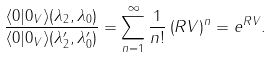Convert formula to latex. <formula><loc_0><loc_0><loc_500><loc_500>\frac { \langle 0 | 0 _ { V } \rangle ( \lambda _ { 2 } , \lambda _ { 0 } ) } { \langle 0 | 0 _ { V } \rangle ( { \lambda } ^ { \prime } _ { 2 } , { \lambda } ^ { \prime } _ { 0 } ) } = \sum ^ { \infty } _ { n = 1 } \frac { 1 } { n ! } \left ( R V \right ) ^ { n } = e ^ { R V } .</formula> 